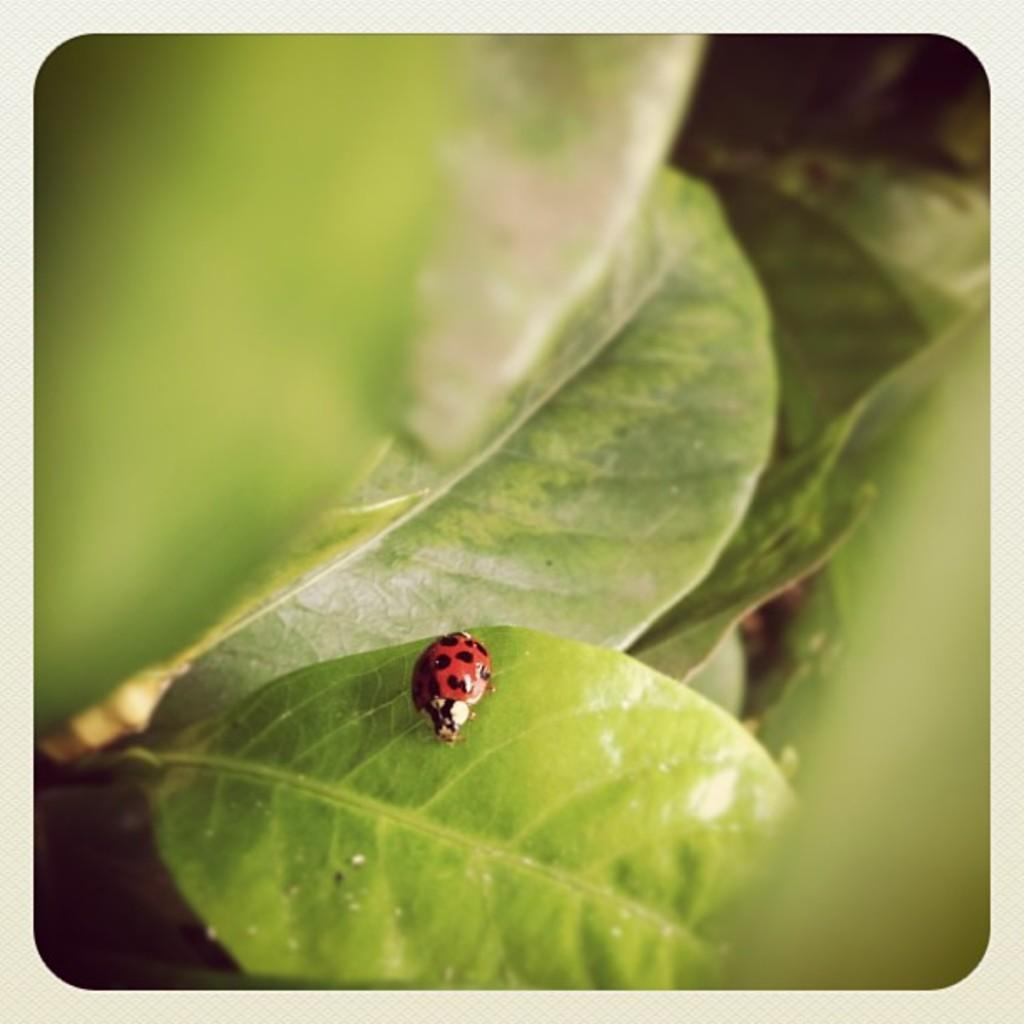What is the main subject of the image? The main subject of the image is a bug on a leaf. Can you describe the bug's location in the image? The bug is on a leaf in the image. Are there any other leaves visible in the image? Yes, there are leaves beside the bug in the image. What type of crack is visible in the image? There is no crack present in the image; it features a bug on a leaf and surrounding leaves. 